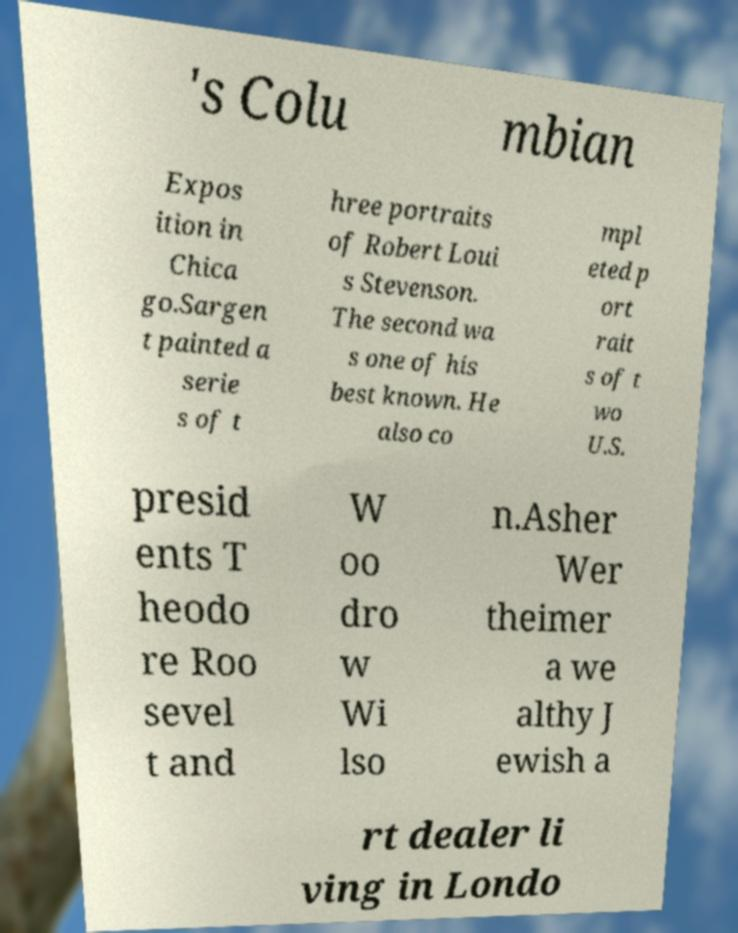Could you extract and type out the text from this image? 's Colu mbian Expos ition in Chica go.Sargen t painted a serie s of t hree portraits of Robert Loui s Stevenson. The second wa s one of his best known. He also co mpl eted p ort rait s of t wo U.S. presid ents T heodo re Roo sevel t and W oo dro w Wi lso n.Asher Wer theimer a we althy J ewish a rt dealer li ving in Londo 